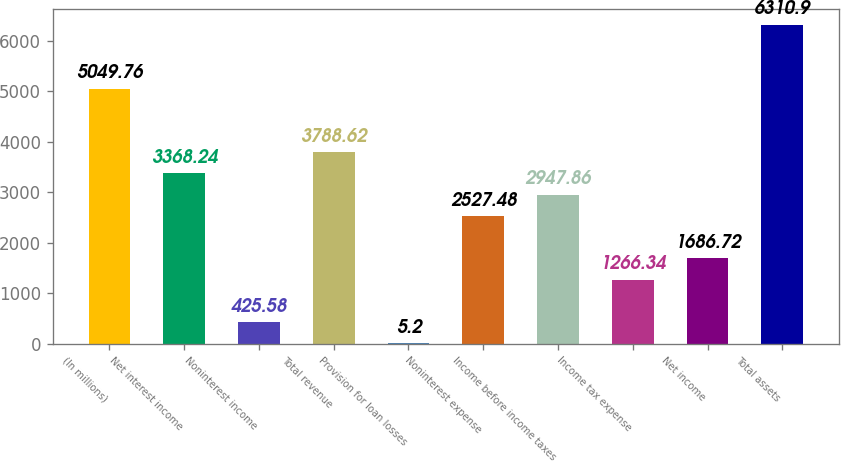Convert chart to OTSL. <chart><loc_0><loc_0><loc_500><loc_500><bar_chart><fcel>(In millions)<fcel>Net interest income<fcel>Noninterest income<fcel>Total revenue<fcel>Provision for loan losses<fcel>Noninterest expense<fcel>Income before income taxes<fcel>Income tax expense<fcel>Net income<fcel>Total assets<nl><fcel>5049.76<fcel>3368.24<fcel>425.58<fcel>3788.62<fcel>5.2<fcel>2527.48<fcel>2947.86<fcel>1266.34<fcel>1686.72<fcel>6310.9<nl></chart> 